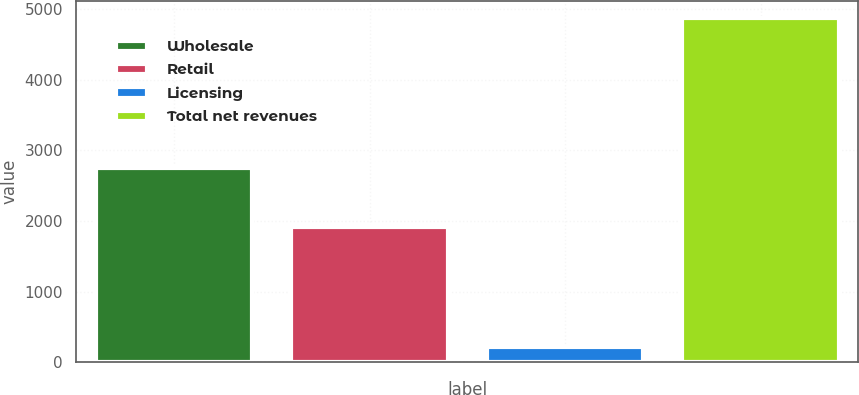<chart> <loc_0><loc_0><loc_500><loc_500><bar_chart><fcel>Wholesale<fcel>Retail<fcel>Licensing<fcel>Total net revenues<nl><fcel>2758.1<fcel>1912.6<fcel>209.4<fcel>4880.1<nl></chart> 